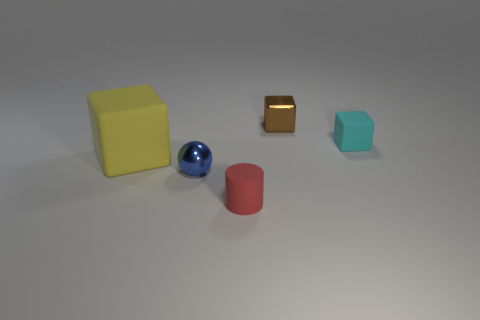Add 4 green rubber spheres. How many objects exist? 9 Subtract all cubes. How many objects are left? 2 Add 4 small red rubber things. How many small red rubber things exist? 5 Subtract 0 purple cubes. How many objects are left? 5 Subtract all red matte things. Subtract all brown metallic blocks. How many objects are left? 3 Add 2 blue metal balls. How many blue metal balls are left? 3 